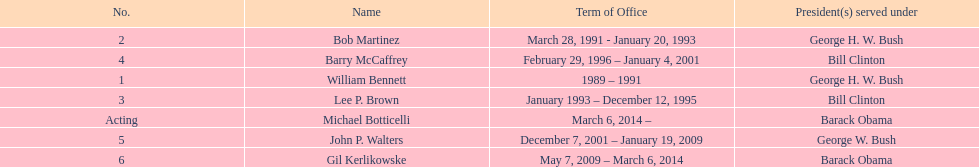What were the number of directors that stayed in office more than three years? 3. 